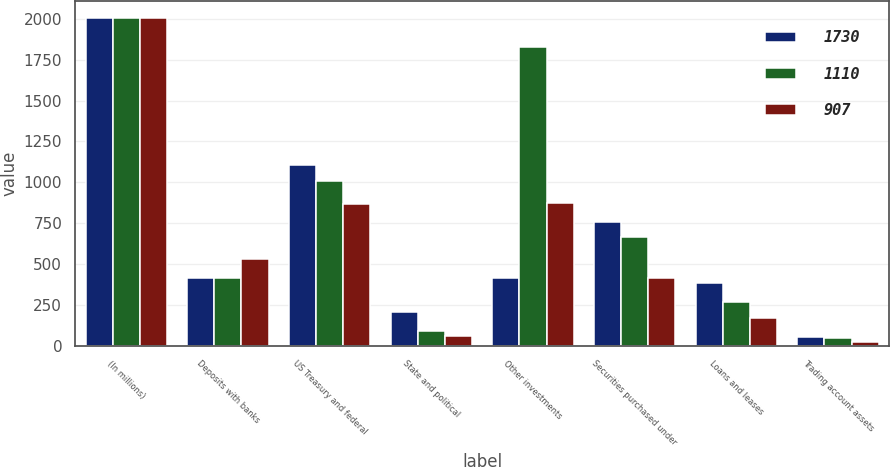Convert chart. <chart><loc_0><loc_0><loc_500><loc_500><stacked_bar_chart><ecel><fcel>(In millions)<fcel>Deposits with banks<fcel>US Treasury and federal<fcel>State and political<fcel>Other investments<fcel>Securities purchased under<fcel>Loans and leases<fcel>Trading account assets<nl><fcel>1730<fcel>2007<fcel>416<fcel>1106<fcel>205<fcel>416<fcel>756<fcel>382<fcel>55<nl><fcel>1110<fcel>2006<fcel>414<fcel>1011<fcel>88<fcel>1830<fcel>663<fcel>270<fcel>48<nl><fcel>907<fcel>2005<fcel>529<fcel>866<fcel>58<fcel>873<fcel>412<fcel>171<fcel>21<nl></chart> 